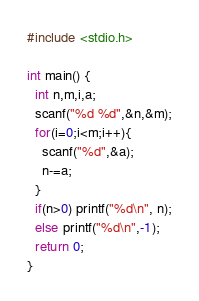<code> <loc_0><loc_0><loc_500><loc_500><_C_>#include <stdio.h>

int main() {
  int n,m,i,a;
  scanf("%d %d",&n,&m);
  for(i=0;i<m;i++){
    scanf("%d",&a);
    n-=a;
  }
  if(n>0) printf("%d\n", n);
  else printf("%d\n",-1);
  return 0;
}
</code> 